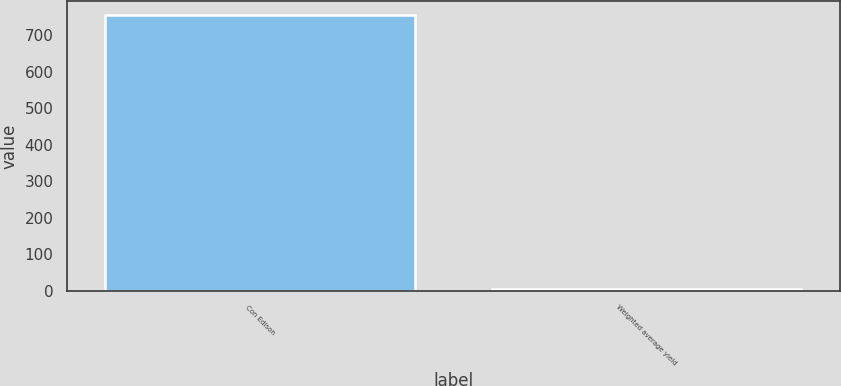Convert chart. <chart><loc_0><loc_0><loc_500><loc_500><bar_chart><fcel>Con Edison<fcel>Weighted average yield<nl><fcel>755<fcel>4.3<nl></chart> 